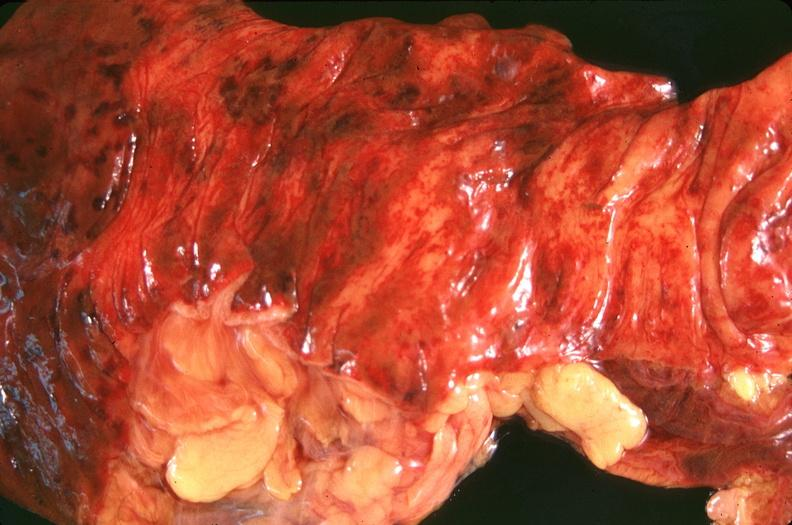what does this image show?
Answer the question using a single word or phrase. Small intestine 